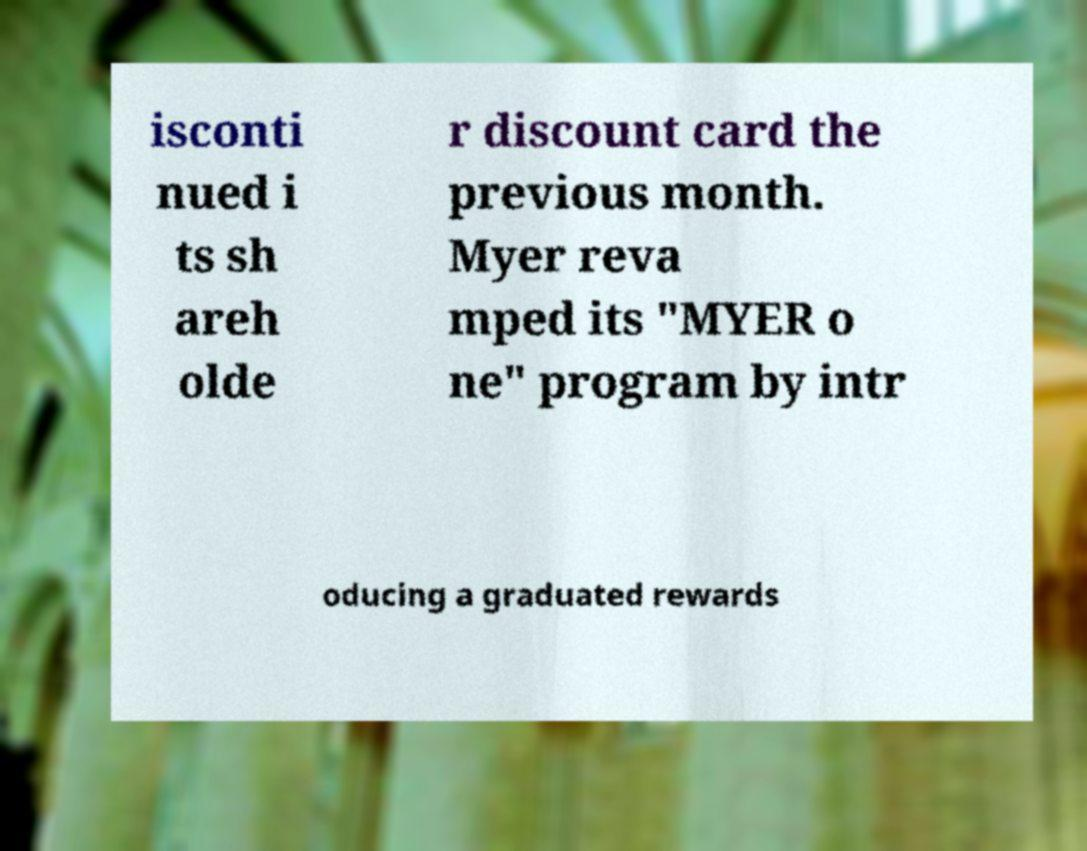Please read and relay the text visible in this image. What does it say? isconti nued i ts sh areh olde r discount card the previous month. Myer reva mped its "MYER o ne" program by intr oducing a graduated rewards 